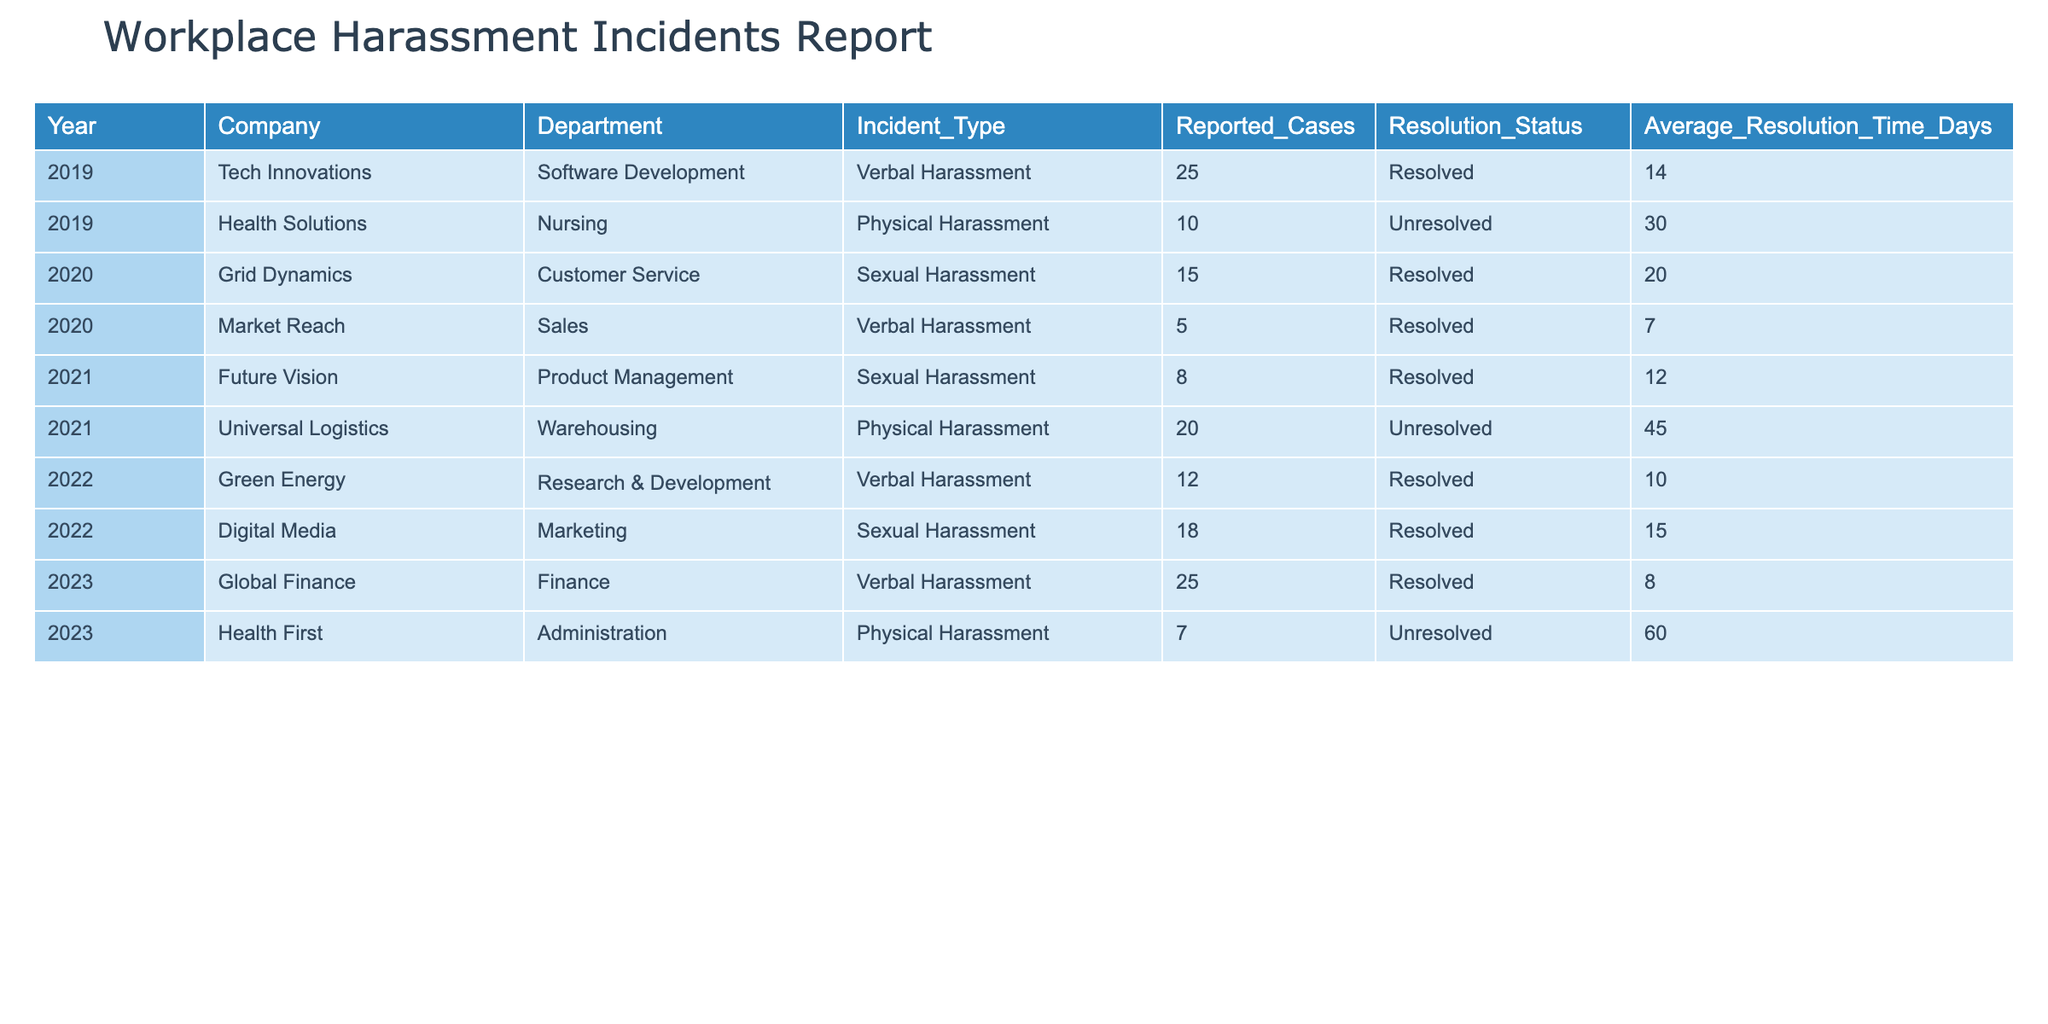What is the total number of reported cases of sexual harassment from 2019 to 2023? To find the total number of reported cases of sexual harassment, we look for the rows corresponding to "Sexual Harassment" in the Incident_Type column. The reported cases are 15 (2020) + 8 (2021) + 18 (2022) = 41. The table does not have any reported cases of sexual harassment in 2019 or 2023, which means the final total is 41.
Answer: 41 Which year had the highest number of reported cases of physical harassment? We identify the rows that indicate "Physical Harassment" in the Incident_Type column. The reported cases are 10 (2019), 20 (2021), and 7 (2023). Comparing these values, the highest is 20 in 2021.
Answer: 2021 What is the average resolution time for unresolved cases from 2019 to 2023? We first filter and find unresolved cases from the table, which are 30 days (2019) and 45 days (2021), and 60 days (2023). The average resolution time is calculated as (30 + 45 + 60) / 3 = 135 / 3 = 45 days.
Answer: 45 days Does the Finance department report any cases of verbal harassment in 2023? We check the table for the year 2023 and see if there are any rows for the Finance department with "Verbal Harassment." The table shows that there were indeed 25 cases recorded. Thus, the answer is yes.
Answer: Yes What percentage of reported cases for verbal harassment were resolved by 2023? We gather data for verbal harassment: 25 (2019, resolved), 5 (2020, resolved), 0 (2021, no cases), 12 (2022, resolved), and 25 (2023, resolved). The total reported cases for verbal harassment is 25 + 5 + 0 + 12 + 25 = 67, and the resolved cases total 25 + 5 + 12 + 25 = 67. Thus the percentage of resolved cases is (67 / 67) * 100 = 100%.
Answer: 100% 